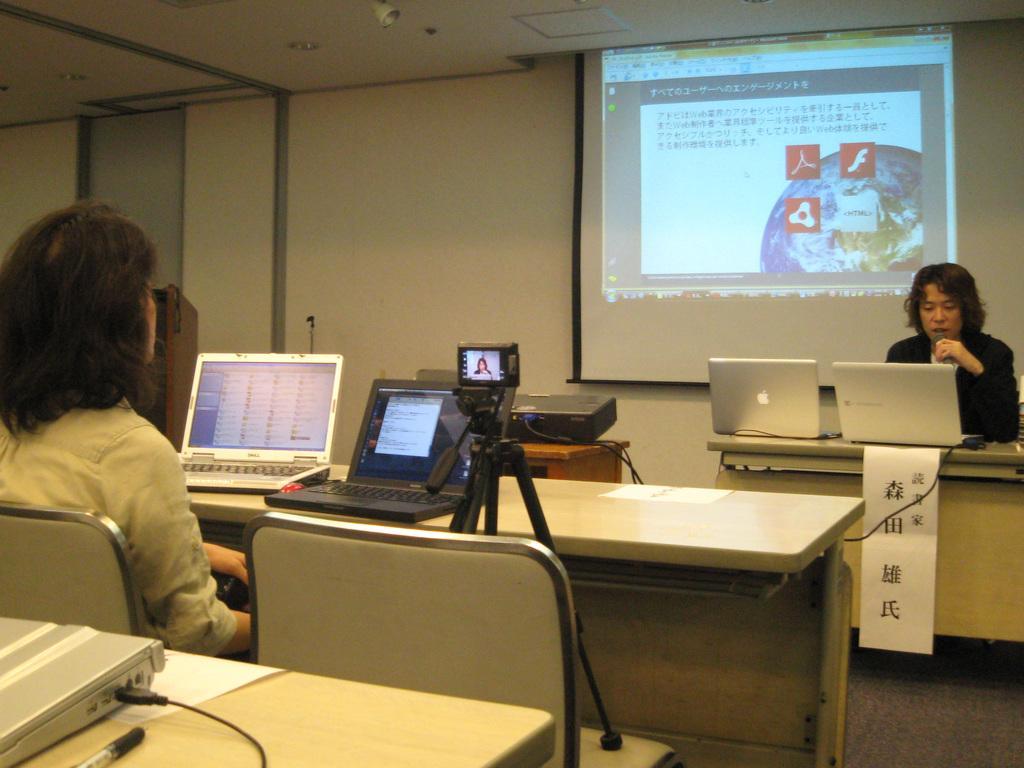Describe this image in one or two sentences. In this image i can see a woman sitting on a chair there is a laptop on a table in front of a woman at the back ground i can see the other woman in front of a laptop and a projector. 